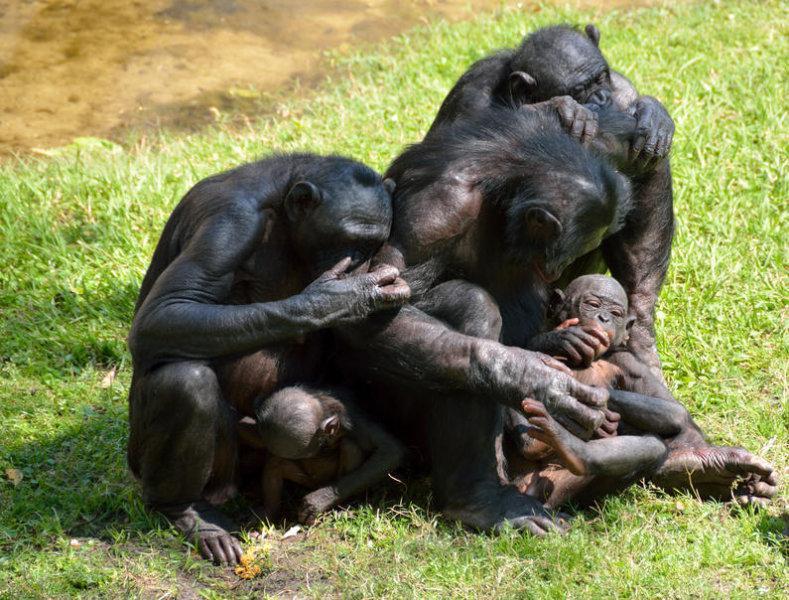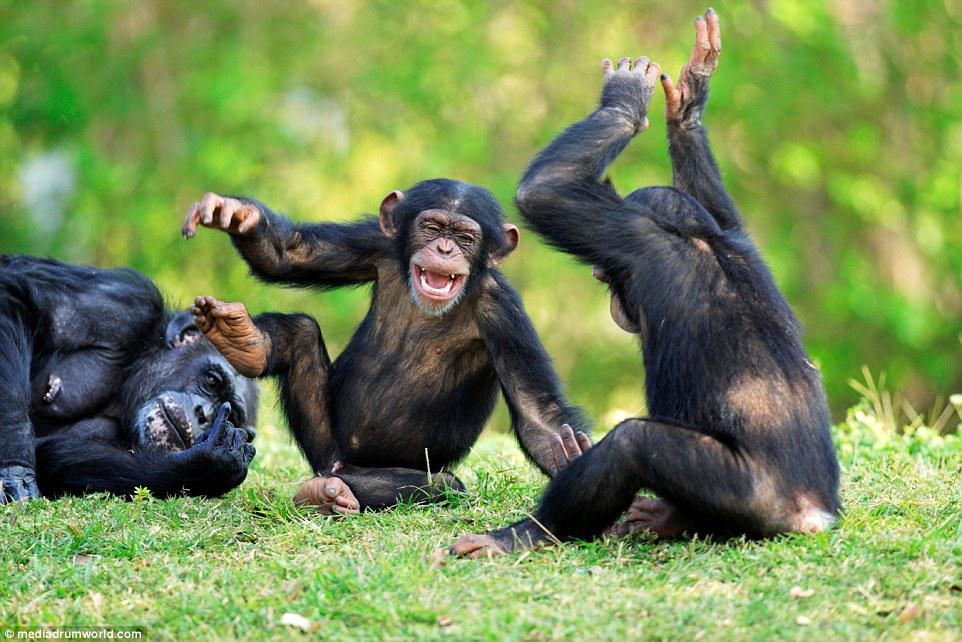The first image is the image on the left, the second image is the image on the right. For the images shown, is this caption "There are multiple chimps outside in the image on the right." true? Answer yes or no. Yes. The first image is the image on the left, the second image is the image on the right. Evaluate the accuracy of this statement regarding the images: "There are at most two chimpanzees.". Is it true? Answer yes or no. No. The first image is the image on the left, the second image is the image on the right. Analyze the images presented: Is the assertion "An image contains one chimp, with arms folded across its chest and a wide, open grin on its face." valid? Answer yes or no. No. 